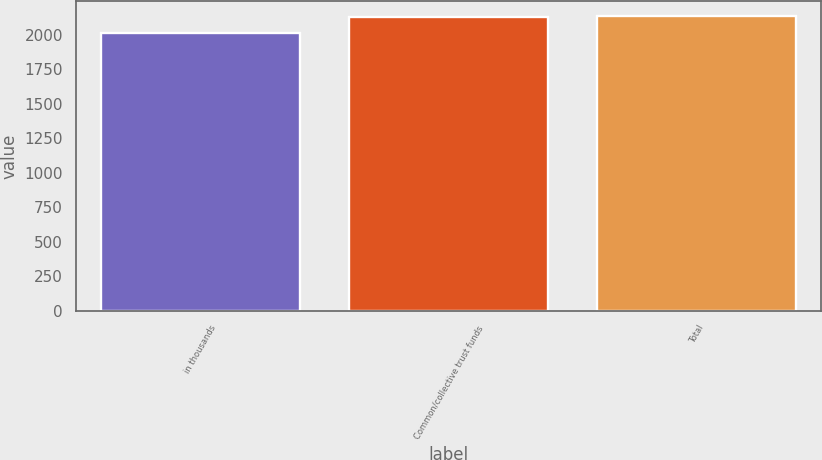Convert chart to OTSL. <chart><loc_0><loc_0><loc_500><loc_500><bar_chart><fcel>in thousands<fcel>Common/collective trust funds<fcel>Total<nl><fcel>2015<fcel>2124<fcel>2134.9<nl></chart> 